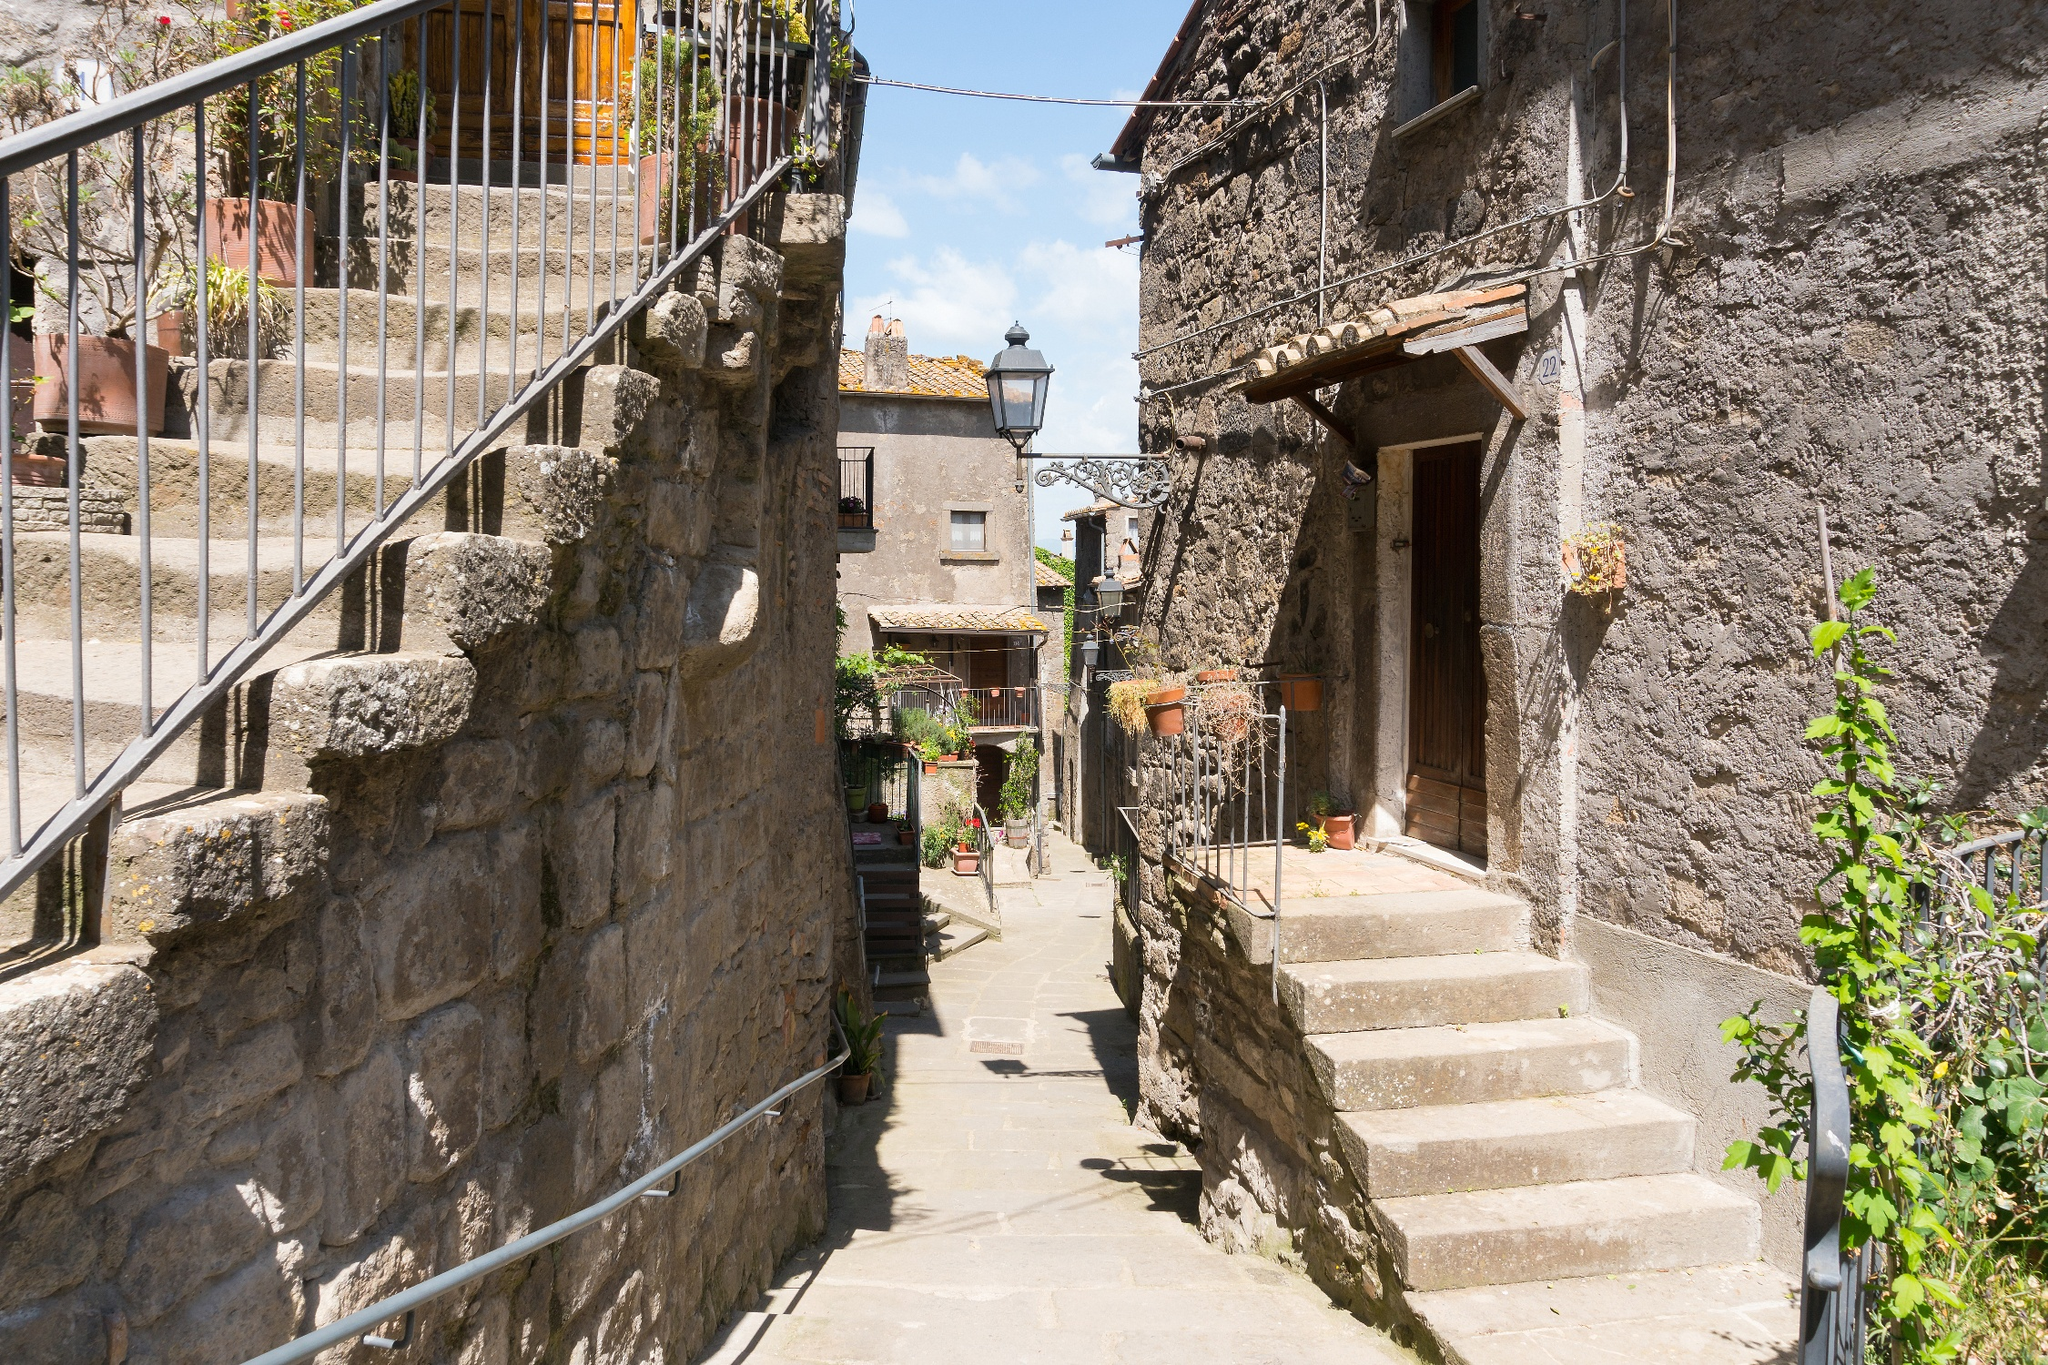Imagine you are living in this village. What daily activities would take place here? Living in this picturesque village, daily activities would likely include morning strolls along the cobblestone alleyways, where locals exchange greetings and news of the day. Residents might step out to water their potted plants, adding a splash of green to the stone surroundings. In the courtyard, children might play around the fountain while elders engage in relaxed conversations on benches. The light sound of a broom sweeping the path echoes as shopkeepers tidy up. Afternoons could be filled with market visits, where fresh produce and local crafts are exchanged. As evening approaches, families might gather for meals under the setting sun, the aroma of home-cooked food wafting through the air. The day would end with peaceful walks under the gentle glow of street lanterns, encapsulating the essence of village life. 